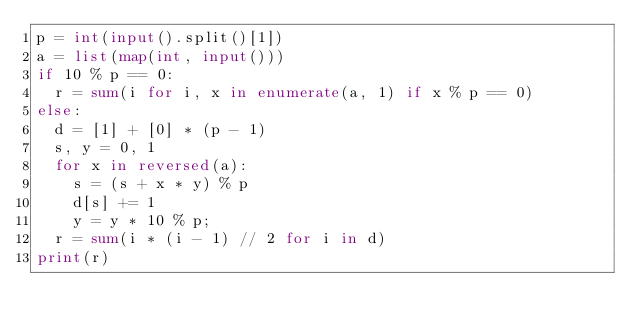<code> <loc_0><loc_0><loc_500><loc_500><_Python_>p = int(input().split()[1])
a = list(map(int, input()))
if 10 % p == 0:
  r = sum(i for i, x in enumerate(a, 1) if x % p == 0)
else:
  d = [1] + [0] * (p - 1)
  s, y = 0, 1
  for x in reversed(a):
    s = (s + x * y) % p
    d[s] += 1
    y = y * 10 % p;
  r = sum(i * (i - 1) // 2 for i in d)
print(r)</code> 